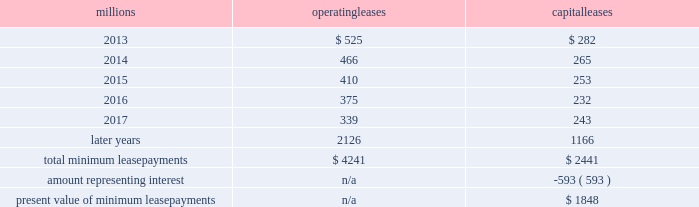Fixed-price purchase options available in the leases could potentially provide benefits to us ; however , these benefits are not expected to be significant .
We maintain and operate the assets based on contractual obligations within the lease arrangements , which set specific guidelines consistent within the railroad industry .
As such , we have no control over activities that could materially impact the fair value of the leased assets .
We do not hold the power to direct the activities of the vies and , therefore , do not control the ongoing activities that have a significant impact on the economic performance of the vies .
Additionally , we do not have the obligation to absorb losses of the vies or the right to receive benefits of the vies that could potentially be significant to the we are not considered to be the primary beneficiary and do not consolidate these vies because our actions and decisions do not have the most significant effect on the vie 2019s performance and our fixed-price purchase price options are not considered to be potentially significant to the vie 2019s .
The future minimum lease payments associated with the vie leases totaled $ 3.6 billion as of december 31 , 2012 .
16 .
Leases we lease certain locomotives , freight cars , and other property .
The consolidated statements of financial position as of december 31 , 2012 and 2011 included $ 2467 million , net of $ 966 million of accumulated depreciation , and $ 2458 million , net of $ 915 million of accumulated depreciation , respectively , for properties held under capital leases .
A charge to income resulting from the depreciation for assets held under capital leases is included within depreciation expense in our consolidated statements of income .
Future minimum lease payments for operating and capital leases with initial or remaining non-cancelable lease terms in excess of one year as of december 31 , 2012 , were as follows : millions operating leases capital leases .
Approximately 94% ( 94 % ) of capital lease payments relate to locomotives .
Rent expense for operating leases with terms exceeding one month was $ 631 million in 2012 , $ 637 million in 2011 , and $ 624 million in 2010 .
When cash rental payments are not made on a straight-line basis , we recognize variable rental expense on a straight-line basis over the lease term .
Contingent rentals and sub-rentals are not significant .
17 .
Commitments and contingencies asserted and unasserted claims 2013 various claims and lawsuits are pending against us and certain of our subsidiaries .
We cannot fully determine the effect of all asserted and unasserted claims on our consolidated results of operations , financial condition , or liquidity ; however , to the extent possible , where asserted and unasserted claims are considered probable and where such claims can be reasonably estimated , we have recorded a liability .
We do not expect that any known lawsuits , claims , environmental costs , commitments , contingent liabilities , or guarantees will have a material adverse effect on our consolidated results of operations , financial condition , or liquidity after taking into account liabilities and insurance recoveries previously recorded for these matters .
Personal injury 2013 the cost of personal injuries to employees and others related to our activities is charged to expense based on estimates of the ultimate cost and number of incidents each year .
We use an actuarial analysis to measure the expense and liability , including unasserted claims .
The federal employers 2019 liability act ( fela ) governs compensation for work-related accidents .
Under fela , damages .
If vies were consolidated , what would the total minimum lease payments increase to , in millions? 
Computations: (((3.6 * 1000) + 4241) + 2441)
Answer: 10282.0. 